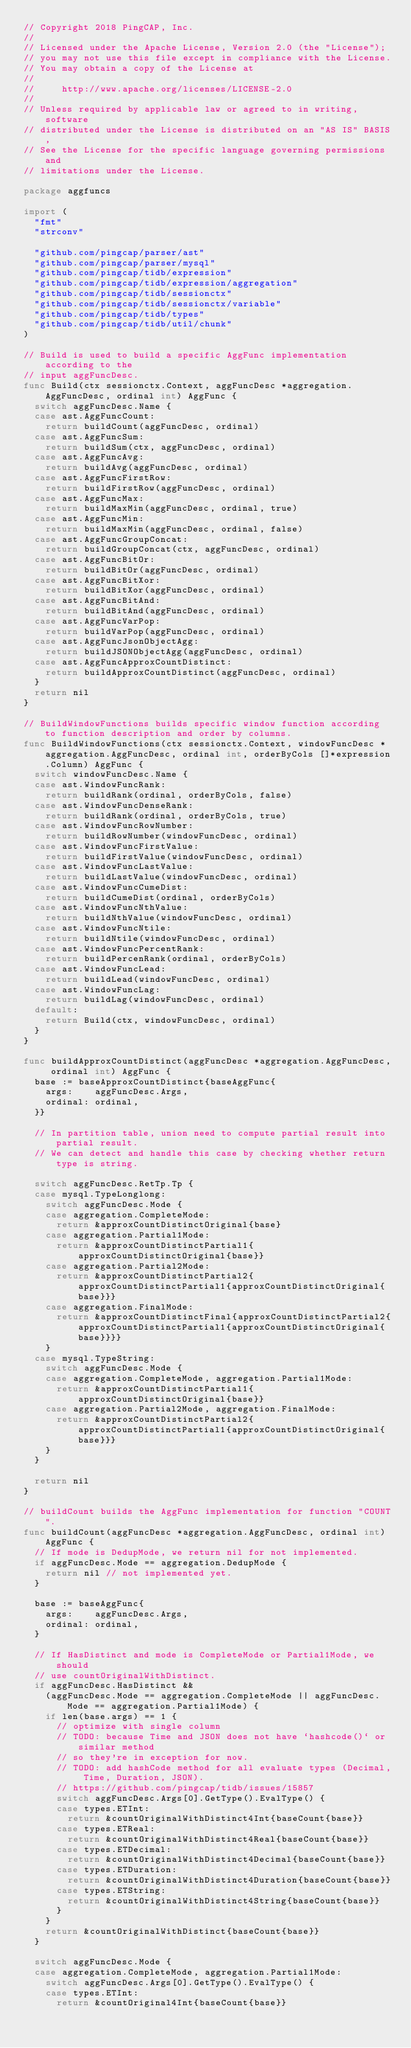<code> <loc_0><loc_0><loc_500><loc_500><_Go_>// Copyright 2018 PingCAP, Inc.
//
// Licensed under the Apache License, Version 2.0 (the "License");
// you may not use this file except in compliance with the License.
// You may obtain a copy of the License at
//
//     http://www.apache.org/licenses/LICENSE-2.0
//
// Unless required by applicable law or agreed to in writing, software
// distributed under the License is distributed on an "AS IS" BASIS,
// See the License for the specific language governing permissions and
// limitations under the License.

package aggfuncs

import (
	"fmt"
	"strconv"

	"github.com/pingcap/parser/ast"
	"github.com/pingcap/parser/mysql"
	"github.com/pingcap/tidb/expression"
	"github.com/pingcap/tidb/expression/aggregation"
	"github.com/pingcap/tidb/sessionctx"
	"github.com/pingcap/tidb/sessionctx/variable"
	"github.com/pingcap/tidb/types"
	"github.com/pingcap/tidb/util/chunk"
)

// Build is used to build a specific AggFunc implementation according to the
// input aggFuncDesc.
func Build(ctx sessionctx.Context, aggFuncDesc *aggregation.AggFuncDesc, ordinal int) AggFunc {
	switch aggFuncDesc.Name {
	case ast.AggFuncCount:
		return buildCount(aggFuncDesc, ordinal)
	case ast.AggFuncSum:
		return buildSum(ctx, aggFuncDesc, ordinal)
	case ast.AggFuncAvg:
		return buildAvg(aggFuncDesc, ordinal)
	case ast.AggFuncFirstRow:
		return buildFirstRow(aggFuncDesc, ordinal)
	case ast.AggFuncMax:
		return buildMaxMin(aggFuncDesc, ordinal, true)
	case ast.AggFuncMin:
		return buildMaxMin(aggFuncDesc, ordinal, false)
	case ast.AggFuncGroupConcat:
		return buildGroupConcat(ctx, aggFuncDesc, ordinal)
	case ast.AggFuncBitOr:
		return buildBitOr(aggFuncDesc, ordinal)
	case ast.AggFuncBitXor:
		return buildBitXor(aggFuncDesc, ordinal)
	case ast.AggFuncBitAnd:
		return buildBitAnd(aggFuncDesc, ordinal)
	case ast.AggFuncVarPop:
		return buildVarPop(aggFuncDesc, ordinal)
	case ast.AggFuncJsonObjectAgg:
		return buildJSONObjectAgg(aggFuncDesc, ordinal)
	case ast.AggFuncApproxCountDistinct:
		return buildApproxCountDistinct(aggFuncDesc, ordinal)
	}
	return nil
}

// BuildWindowFunctions builds specific window function according to function description and order by columns.
func BuildWindowFunctions(ctx sessionctx.Context, windowFuncDesc *aggregation.AggFuncDesc, ordinal int, orderByCols []*expression.Column) AggFunc {
	switch windowFuncDesc.Name {
	case ast.WindowFuncRank:
		return buildRank(ordinal, orderByCols, false)
	case ast.WindowFuncDenseRank:
		return buildRank(ordinal, orderByCols, true)
	case ast.WindowFuncRowNumber:
		return buildRowNumber(windowFuncDesc, ordinal)
	case ast.WindowFuncFirstValue:
		return buildFirstValue(windowFuncDesc, ordinal)
	case ast.WindowFuncLastValue:
		return buildLastValue(windowFuncDesc, ordinal)
	case ast.WindowFuncCumeDist:
		return buildCumeDist(ordinal, orderByCols)
	case ast.WindowFuncNthValue:
		return buildNthValue(windowFuncDesc, ordinal)
	case ast.WindowFuncNtile:
		return buildNtile(windowFuncDesc, ordinal)
	case ast.WindowFuncPercentRank:
		return buildPercenRank(ordinal, orderByCols)
	case ast.WindowFuncLead:
		return buildLead(windowFuncDesc, ordinal)
	case ast.WindowFuncLag:
		return buildLag(windowFuncDesc, ordinal)
	default:
		return Build(ctx, windowFuncDesc, ordinal)
	}
}

func buildApproxCountDistinct(aggFuncDesc *aggregation.AggFuncDesc, ordinal int) AggFunc {
	base := baseApproxCountDistinct{baseAggFunc{
		args:    aggFuncDesc.Args,
		ordinal: ordinal,
	}}

	// In partition table, union need to compute partial result into partial result.
	// We can detect and handle this case by checking whether return type is string.

	switch aggFuncDesc.RetTp.Tp {
	case mysql.TypeLonglong:
		switch aggFuncDesc.Mode {
		case aggregation.CompleteMode:
			return &approxCountDistinctOriginal{base}
		case aggregation.Partial1Mode:
			return &approxCountDistinctPartial1{approxCountDistinctOriginal{base}}
		case aggregation.Partial2Mode:
			return &approxCountDistinctPartial2{approxCountDistinctPartial1{approxCountDistinctOriginal{base}}}
		case aggregation.FinalMode:
			return &approxCountDistinctFinal{approxCountDistinctPartial2{approxCountDistinctPartial1{approxCountDistinctOriginal{base}}}}
		}
	case mysql.TypeString:
		switch aggFuncDesc.Mode {
		case aggregation.CompleteMode, aggregation.Partial1Mode:
			return &approxCountDistinctPartial1{approxCountDistinctOriginal{base}}
		case aggregation.Partial2Mode, aggregation.FinalMode:
			return &approxCountDistinctPartial2{approxCountDistinctPartial1{approxCountDistinctOriginal{base}}}
		}
	}

	return nil
}

// buildCount builds the AggFunc implementation for function "COUNT".
func buildCount(aggFuncDesc *aggregation.AggFuncDesc, ordinal int) AggFunc {
	// If mode is DedupMode, we return nil for not implemented.
	if aggFuncDesc.Mode == aggregation.DedupMode {
		return nil // not implemented yet.
	}

	base := baseAggFunc{
		args:    aggFuncDesc.Args,
		ordinal: ordinal,
	}

	// If HasDistinct and mode is CompleteMode or Partial1Mode, we should
	// use countOriginalWithDistinct.
	if aggFuncDesc.HasDistinct &&
		(aggFuncDesc.Mode == aggregation.CompleteMode || aggFuncDesc.Mode == aggregation.Partial1Mode) {
		if len(base.args) == 1 {
			// optimize with single column
			// TODO: because Time and JSON does not have `hashcode()` or similar method
			// so they're in exception for now.
			// TODO: add hashCode method for all evaluate types (Decimal, Time, Duration, JSON).
			// https://github.com/pingcap/tidb/issues/15857
			switch aggFuncDesc.Args[0].GetType().EvalType() {
			case types.ETInt:
				return &countOriginalWithDistinct4Int{baseCount{base}}
			case types.ETReal:
				return &countOriginalWithDistinct4Real{baseCount{base}}
			case types.ETDecimal:
				return &countOriginalWithDistinct4Decimal{baseCount{base}}
			case types.ETDuration:
				return &countOriginalWithDistinct4Duration{baseCount{base}}
			case types.ETString:
				return &countOriginalWithDistinct4String{baseCount{base}}
			}
		}
		return &countOriginalWithDistinct{baseCount{base}}
	}

	switch aggFuncDesc.Mode {
	case aggregation.CompleteMode, aggregation.Partial1Mode:
		switch aggFuncDesc.Args[0].GetType().EvalType() {
		case types.ETInt:
			return &countOriginal4Int{baseCount{base}}</code> 